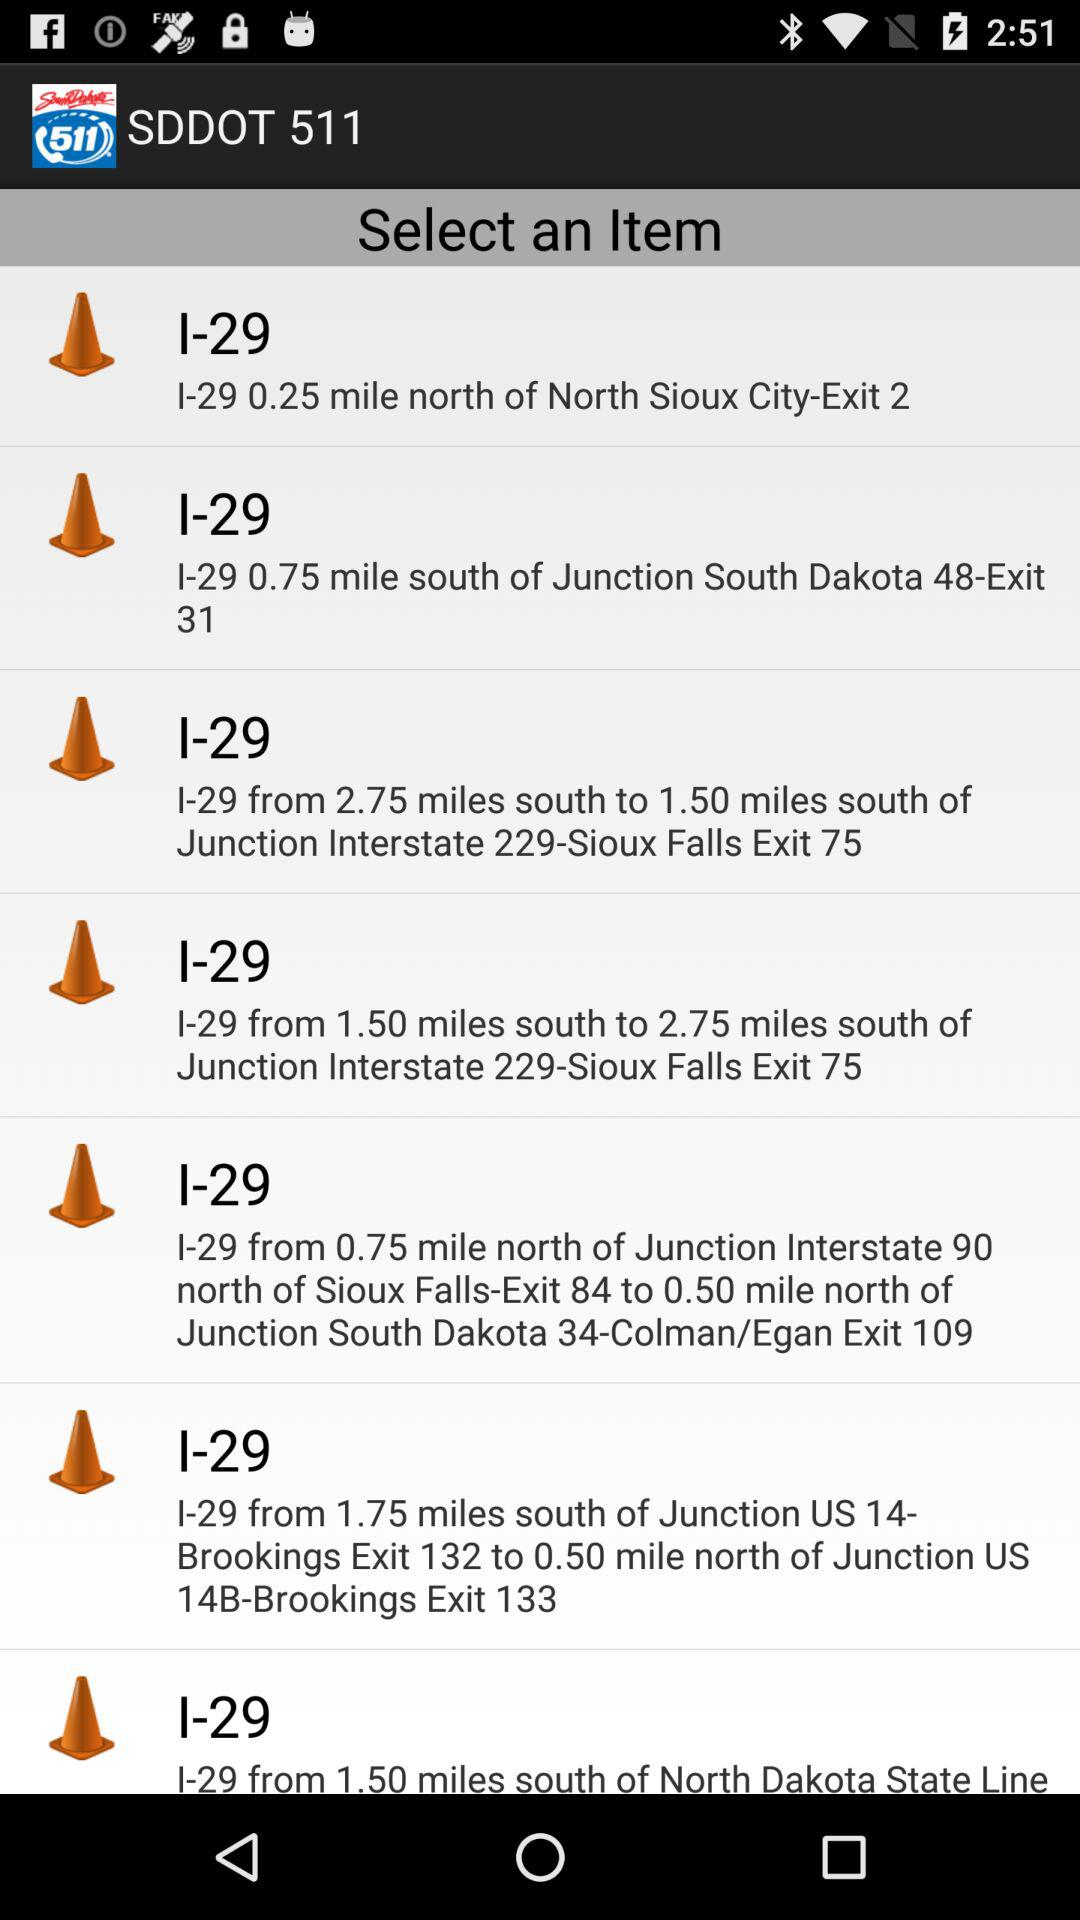I-29 is how many miles from south to 2.75 miles south of junction interstate 229? I-29 is 1.50 miles from south to 2.75 miles south of junction interstate 229. 